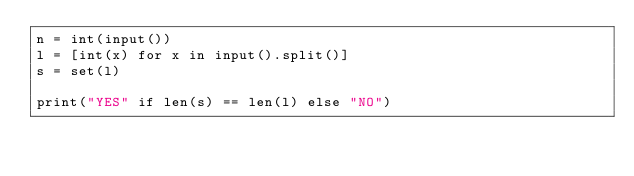Convert code to text. <code><loc_0><loc_0><loc_500><loc_500><_Python_>n = int(input())
l = [int(x) for x in input().split()]
s = set(l)

print("YES" if len(s) == len(l) else "NO")</code> 